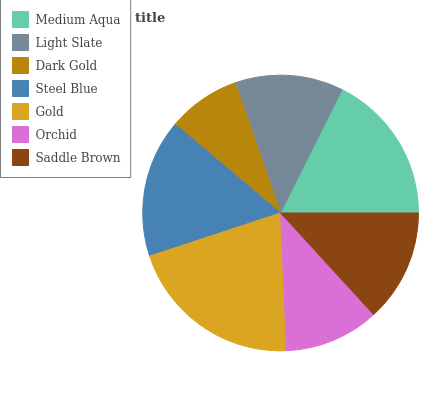Is Dark Gold the minimum?
Answer yes or no. Yes. Is Gold the maximum?
Answer yes or no. Yes. Is Light Slate the minimum?
Answer yes or no. No. Is Light Slate the maximum?
Answer yes or no. No. Is Medium Aqua greater than Light Slate?
Answer yes or no. Yes. Is Light Slate less than Medium Aqua?
Answer yes or no. Yes. Is Light Slate greater than Medium Aqua?
Answer yes or no. No. Is Medium Aqua less than Light Slate?
Answer yes or no. No. Is Saddle Brown the high median?
Answer yes or no. Yes. Is Saddle Brown the low median?
Answer yes or no. Yes. Is Dark Gold the high median?
Answer yes or no. No. Is Steel Blue the low median?
Answer yes or no. No. 